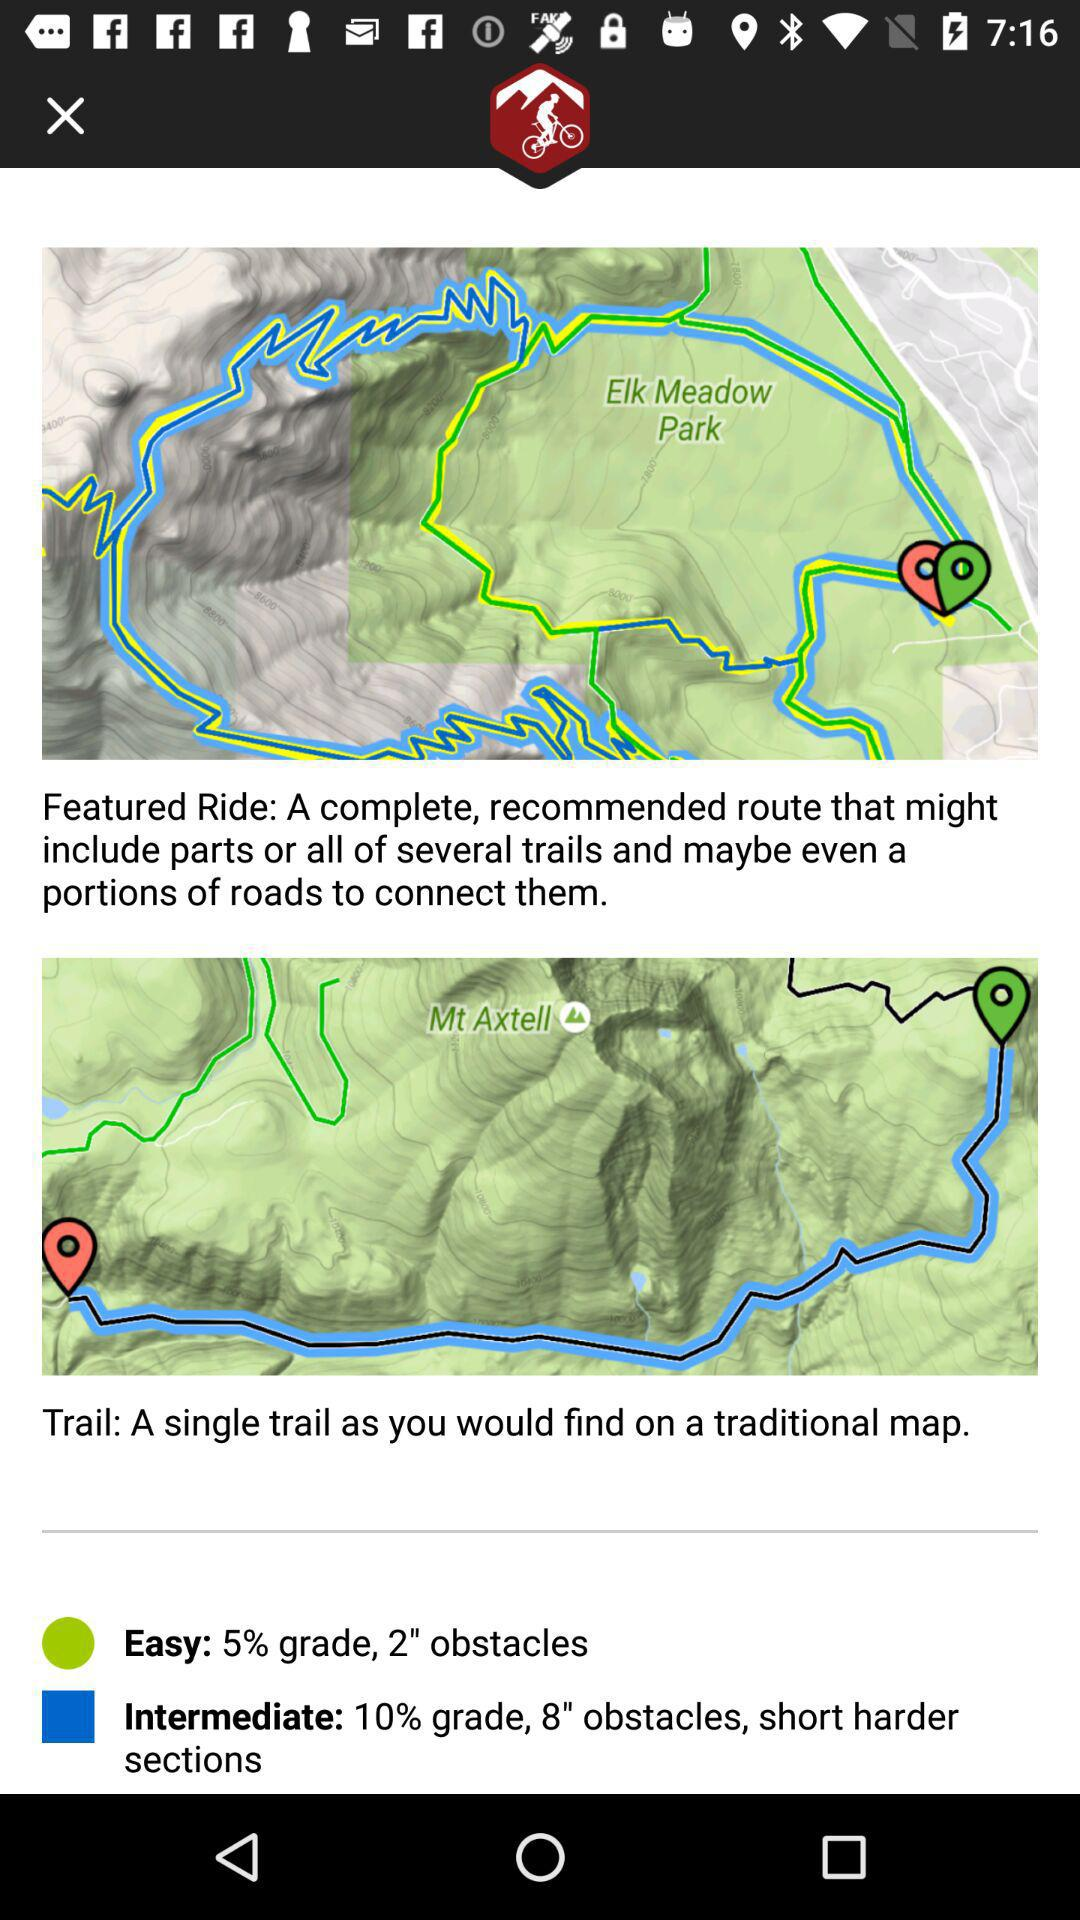How many trail difficulty levels are there?
Answer the question using a single word or phrase. 2 